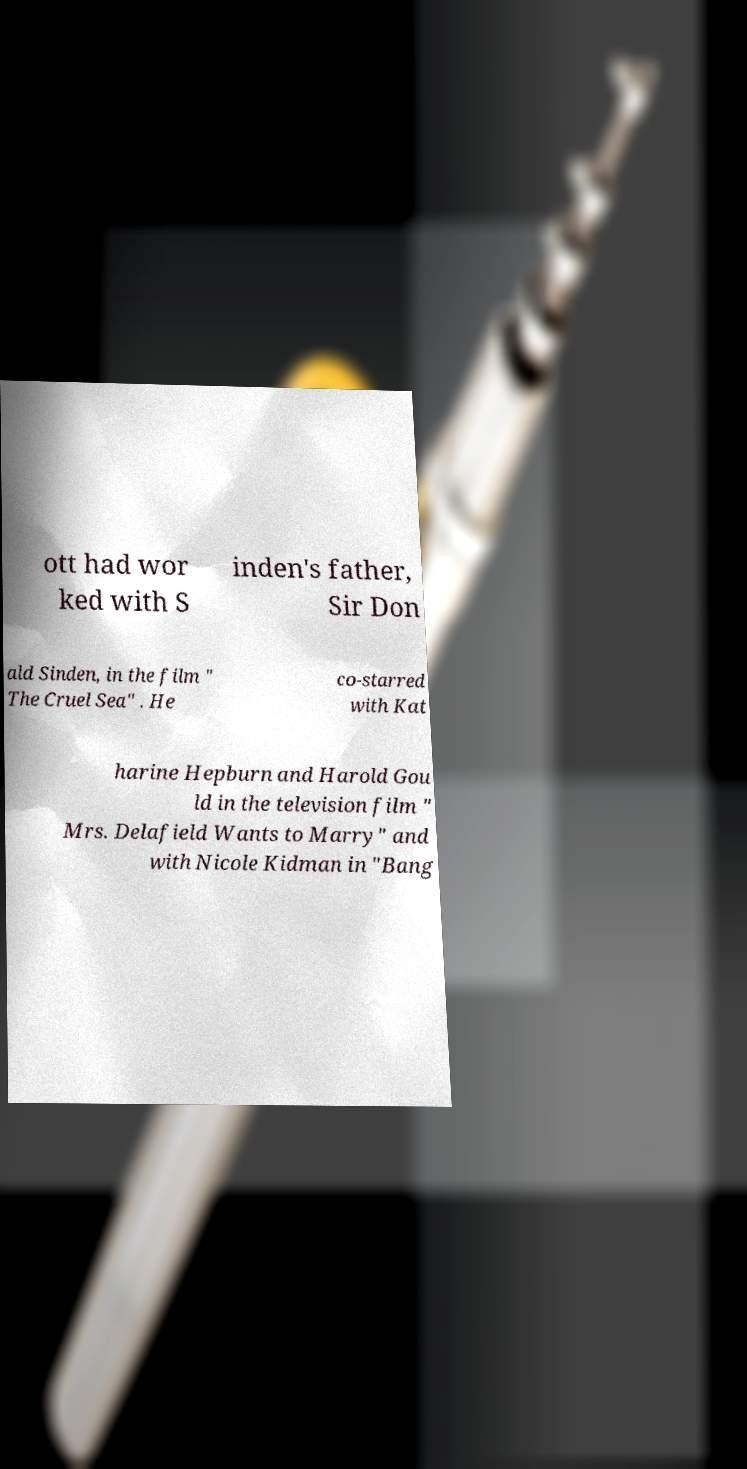Please read and relay the text visible in this image. What does it say? ott had wor ked with S inden's father, Sir Don ald Sinden, in the film " The Cruel Sea" . He co-starred with Kat harine Hepburn and Harold Gou ld in the television film " Mrs. Delafield Wants to Marry" and with Nicole Kidman in "Bang 